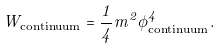<formula> <loc_0><loc_0><loc_500><loc_500>W _ { \text {continuum} } = \frac { 1 } { 4 } m ^ { 2 } \phi _ { \text {continuum} } ^ { 4 } .</formula> 